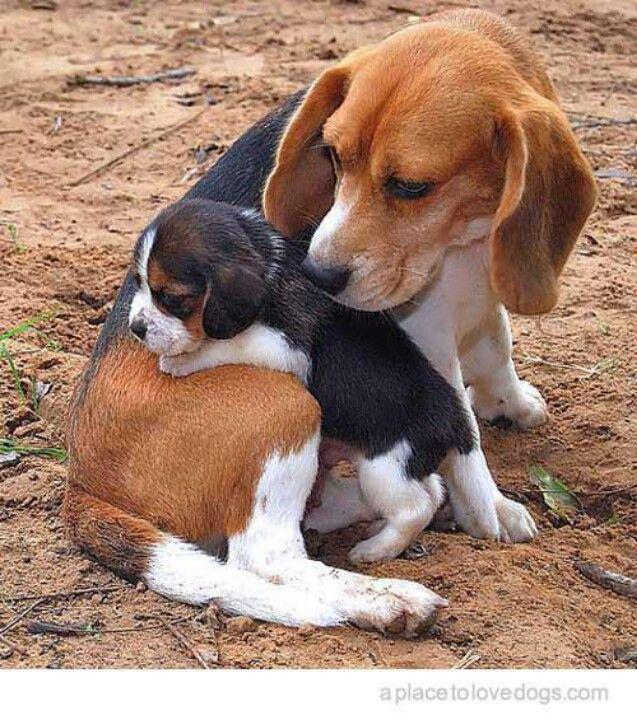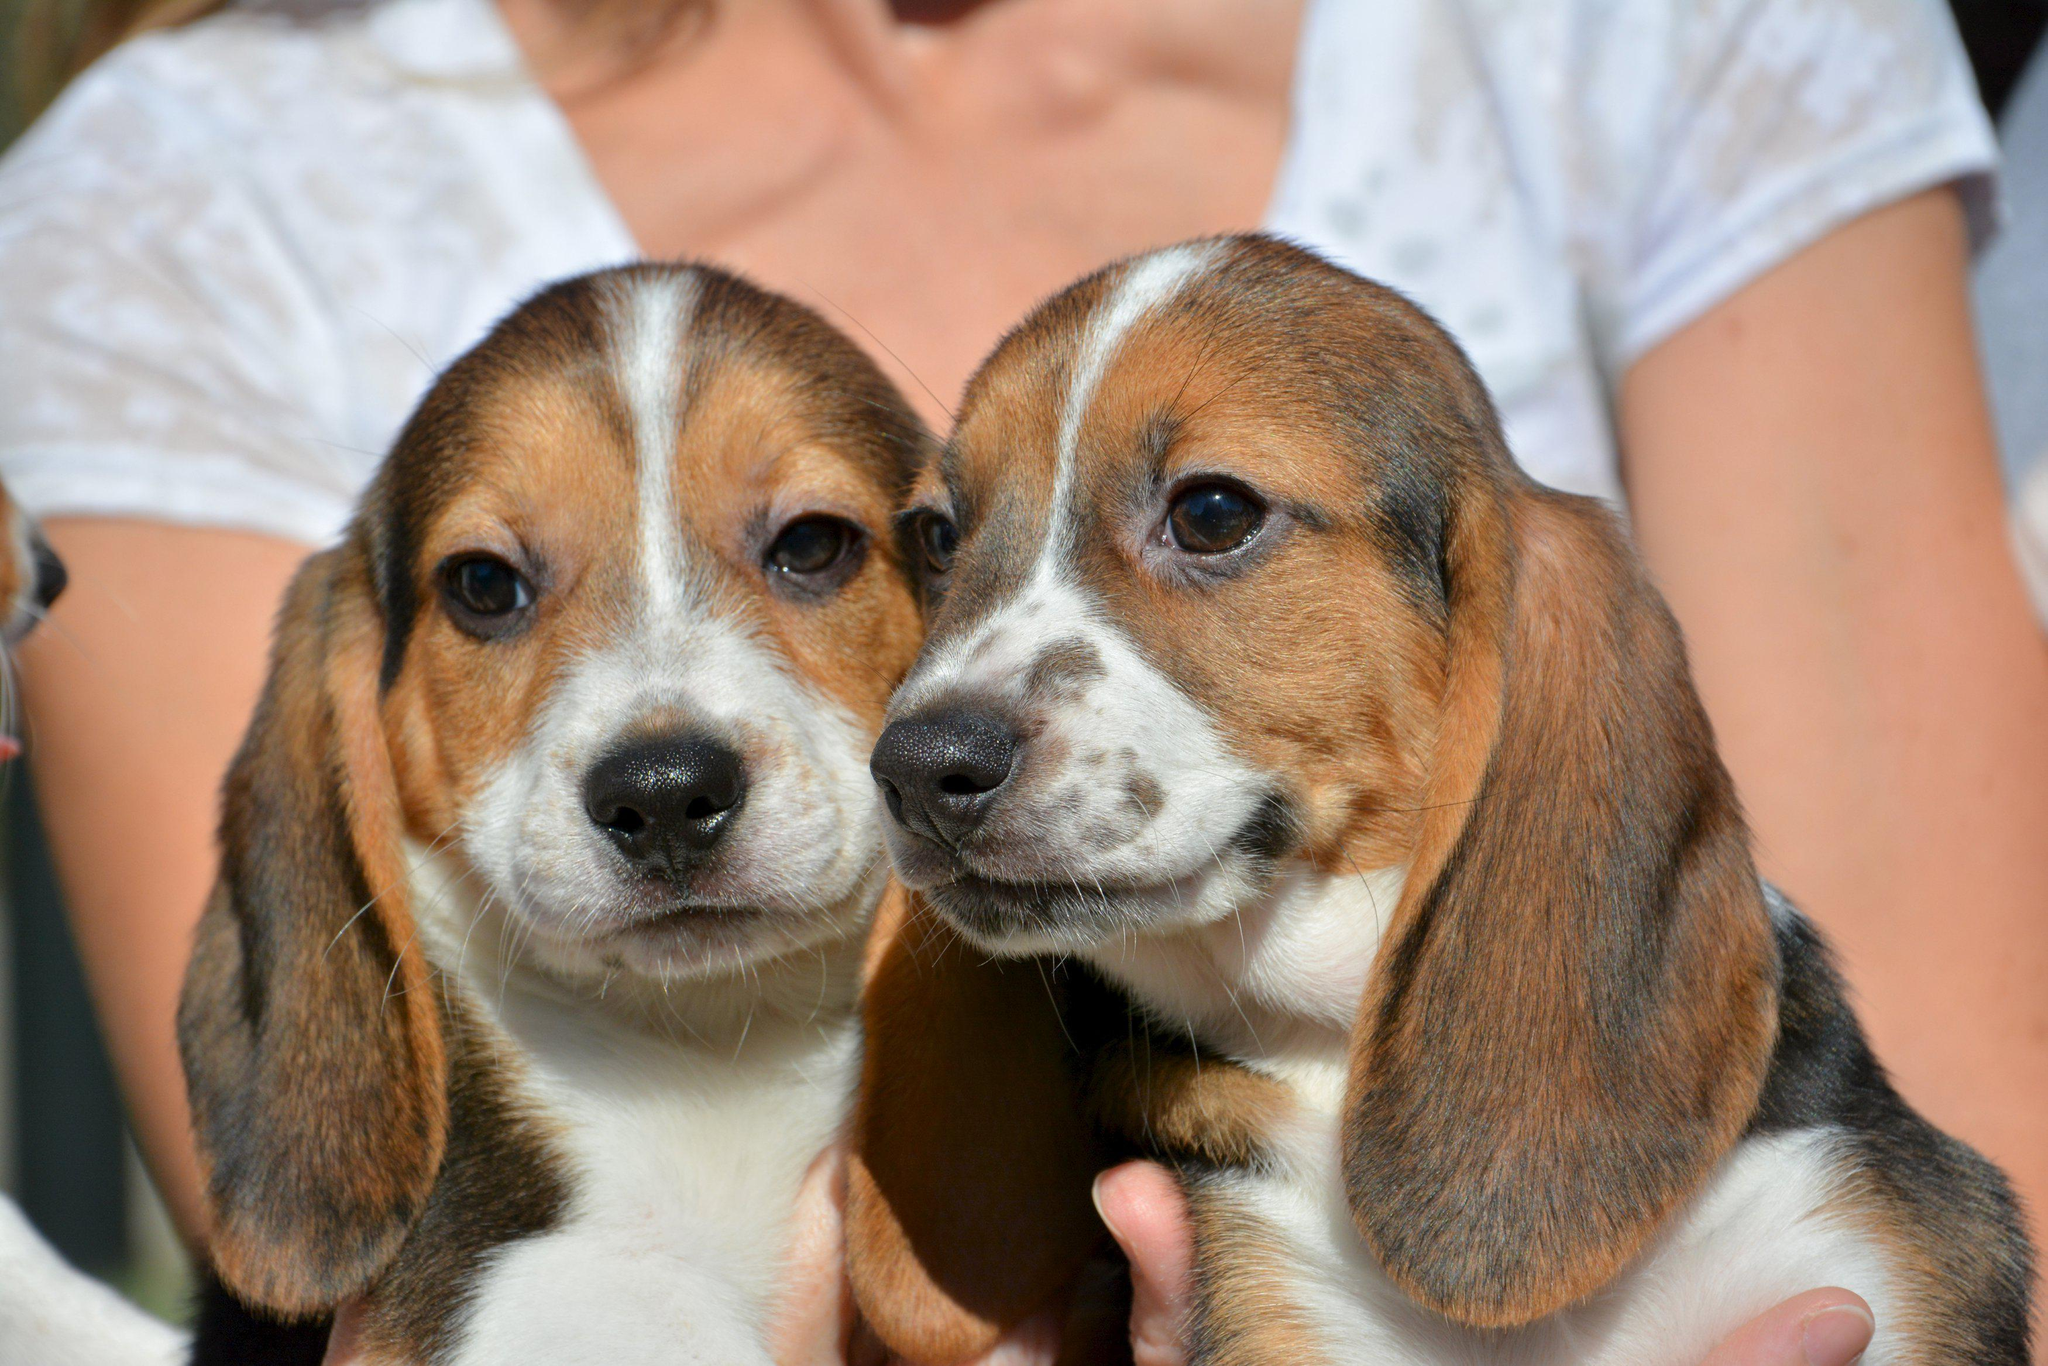The first image is the image on the left, the second image is the image on the right. Examine the images to the left and right. Is the description "An image shows a person's hand around at least one beagle dog." accurate? Answer yes or no. Yes. The first image is the image on the left, the second image is the image on the right. Analyze the images presented: Is the assertion "A single dog is lying down relaxing in the image on the right." valid? Answer yes or no. No. 